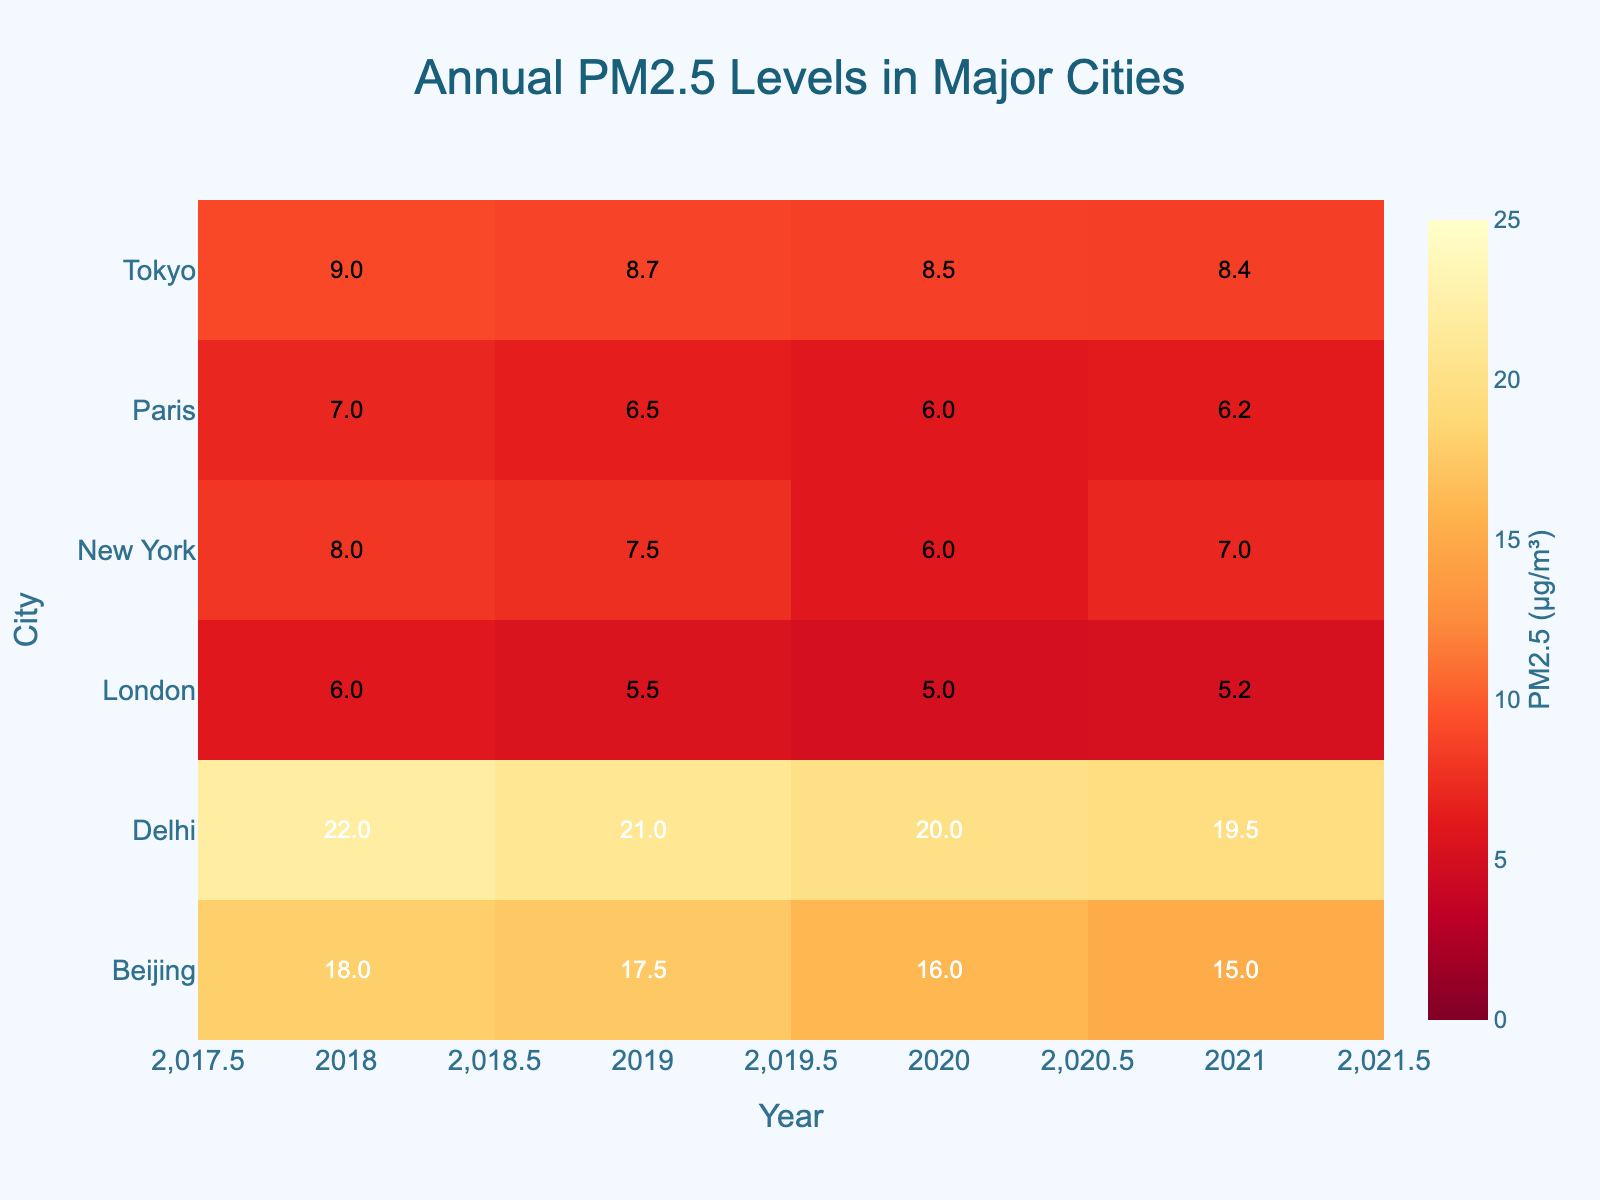What's the title of the heatmap? The title is usually placed at the top of the figure. In this case, it's clear and readable, stating the main focus of the heatmap.
Answer: Annual PM2.5 Levels in Major Cities Which city has the highest PM2.5 level in 2018? Look at the row for the year 2018 and identify the highest value. The city corresponding to this value is the answer.
Answer: Delhi What's the average PM2.5 level for New York from 2018 to 2021? Extract the values for New York from 2018 to 2021: 8, 7.5, 6, and 7. Sum these values and divide by the number of values (4). So, (8 + 7.5 + 6 + 7) / 4 = 7.125
Answer: 7.125 Which city showed the most consistent PM2.5 levels over the years? Consistency can be judged by the least variation in values across different years. Tokyo's values (9, 8.7, 8.5, 8.4) change slightly, indicating high consistency.
Answer: Tokyo In which year did Beijing have the lowest PM2.5 level? Check the row for Beijing and find the lowest value across the years. Identify the corresponding year for this value.
Answer: 2021 Compare the PM2.5 levels of London and Paris in 2020. Which city had a higher level? Look at the values for London and Paris in the year 2020. Compare 5 (London) and 6 (Paris). Paris has a higher value.
Answer: Paris What trend can you observe for Delhi's PM2.5 levels from 2018 to 2021? Observe the values for Delhi across the years: 22, 21, 20, 19.5. There is a consistent decreasing trend.
Answer: Decreasing trend Which city had a PM2.5 value of 8 in 2018? Look at the row for 2018 and identify the city with a PM2.5 value of 8.
Answer: New York Calculate the difference between the highest and lowest PM2.5 levels for Tokyo over the years. Identify Tokyo's PM2.5 values (9, 8.7, 8.5, 8.4). The highest is 9 and the lowest is 8.4. The difference is 9 - 8.4 = 0.6
Answer: 0.6 Between New York and London, which city saw a greater reduction in PM2.5 levels from 2018 to 2021? Subtract the 2021 value from the 2018 value for both cities. New York: 8 - 7 = 1, London: 6 - 5.2 = 0.8. New York saw a greater reduction.
Answer: New York 